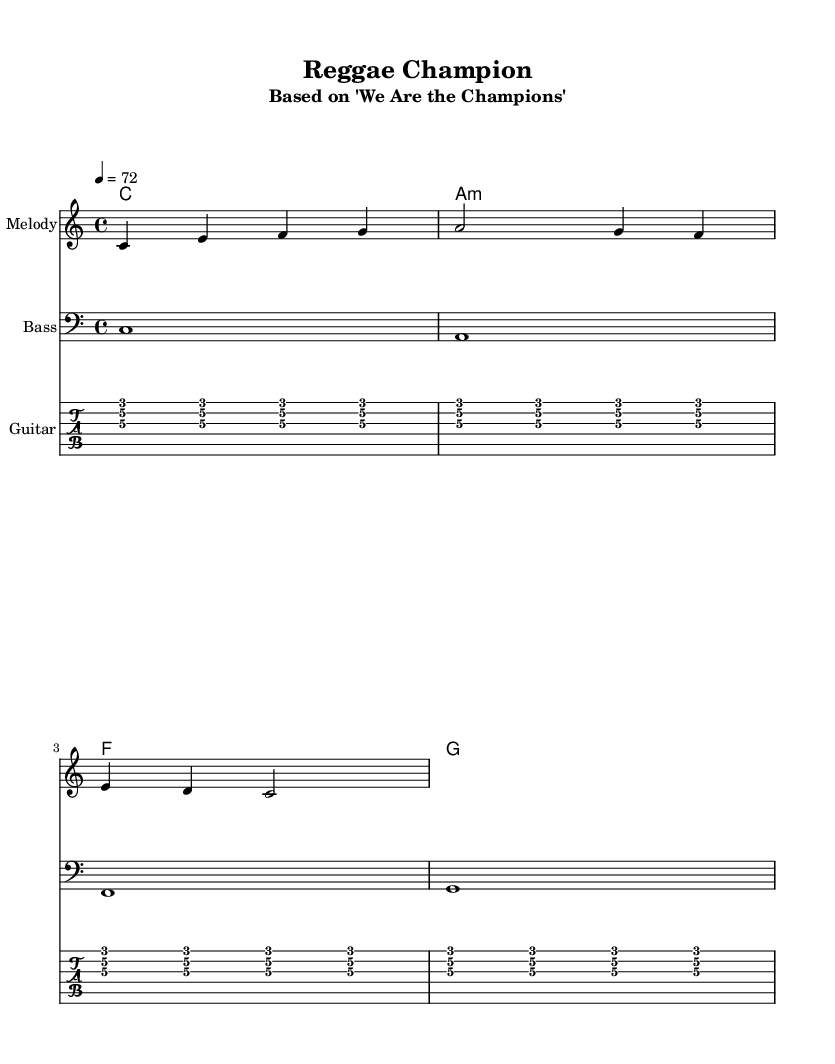What is the key signature of this music? The key signature is indicated at the beginning of the score and is identified as C major, which has no sharps or flats listed.
Answer: C major What is the time signature of this music? The time signature is shown in the upper part of the sheet music, indicated as 4/4, which means there are four beats in each measure.
Answer: 4/4 What is the tempo marking for this piece? The tempo marking is found at the beginning of the score, where it states a tempo of 72 beats per minute, providing a laid-back feel typical of reggae music.
Answer: 72 How many measures are present in the melody line? By counting the groups of notes and bars in the melody section, the total number of measures can be determined to be six.
Answer: 6 What style is this composition categorized under? The style of the piece is reflected in its laid-back rhythm and arrangement, characteristic of reggae, especially highlighting the use of offbeat rhythms.
Answer: Reggae What is the chord progression used in the harmonies? By analyzing the chord symbols listed beneath the melody, the progression can be identified as C, A minor, F, G, which is common in many popular songs.
Answer: C - A minor - F - G Which instrument is playing the rhythm guitar part? The instrument playing the rhythm guitar part is indicated in the tab staff specifically labeled for Guitar, showcasing a rhythmic pattern typical of reggae strumming.
Answer: Guitar 